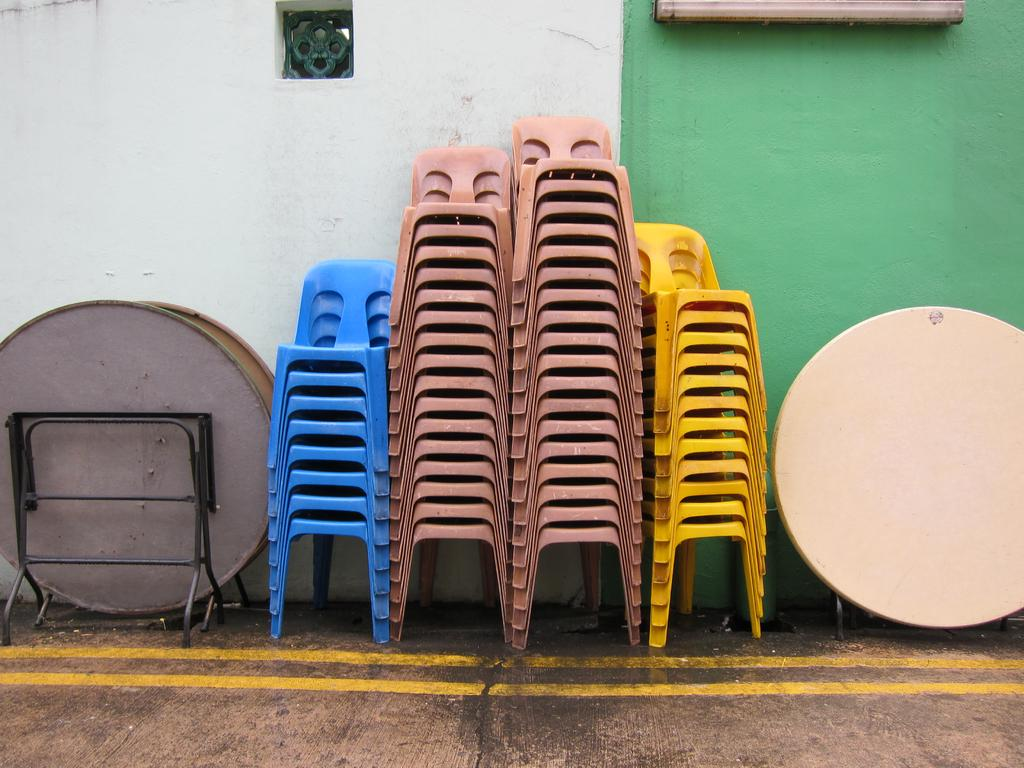What type of furniture is arranged in the image? There is a group of chairs in the image. How are the chairs positioned on the ground? The chairs are placed one on the other on the ground. What other type of furniture can be seen in the image? There are tables in the image. What is the background of the image? There is a wall and a window in the image. What type of lace is used to decorate the chairs in the image? There is no lace present on the chairs in the image. How is the bait arranged on the tables in the image? There is no bait present on the tables in the image. 